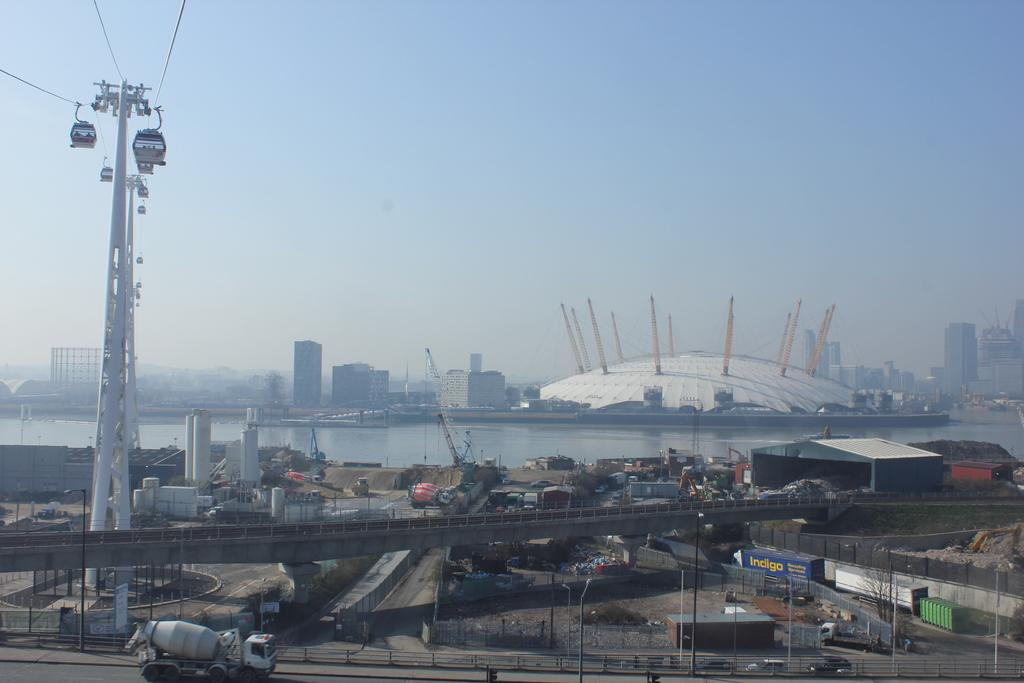What type of structures can be seen in the image? There are poles, cable cars, a bridge, containers, pillars, a shed, towers, and buildings visible in the image. What mode of transportation is present in the image? Cable cars are present in the image. What type of vehicles can be seen in the image? Vehicles are visible in the image. What natural element is present in the image? There is water in the image. What is visible in the background of the image? The sky is visible in the background of the image. What color is the patch on the cable car in the image? There is no patch present on the cable car in the image. How does the pump function in the image? There is no pump present in the image. 